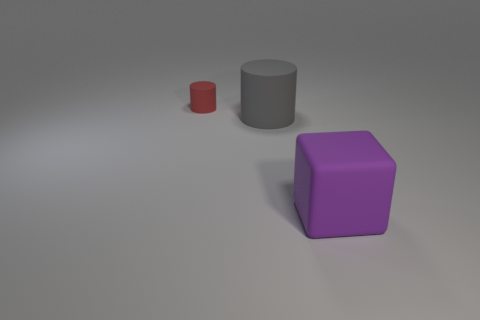There is a matte thing that is behind the cylinder that is in front of the tiny red cylinder; what is its size?
Offer a terse response. Small. What number of large rubber things have the same color as the big cube?
Your answer should be very brief. 0. What number of other objects are there of the same size as the rubber block?
Make the answer very short. 1. What is the size of the thing that is both in front of the small rubber cylinder and to the left of the matte cube?
Your answer should be compact. Large. What number of large purple shiny objects have the same shape as the large gray matte object?
Your answer should be very brief. 0. What is the big cylinder made of?
Make the answer very short. Rubber. Is the shape of the red rubber object the same as the purple object?
Provide a short and direct response. No. Are there any big brown blocks made of the same material as the big purple thing?
Your answer should be compact. No. What is the color of the matte object that is both behind the purple thing and to the right of the red matte cylinder?
Provide a short and direct response. Gray. There is a large thing on the right side of the big gray cylinder; what material is it?
Provide a short and direct response. Rubber. 